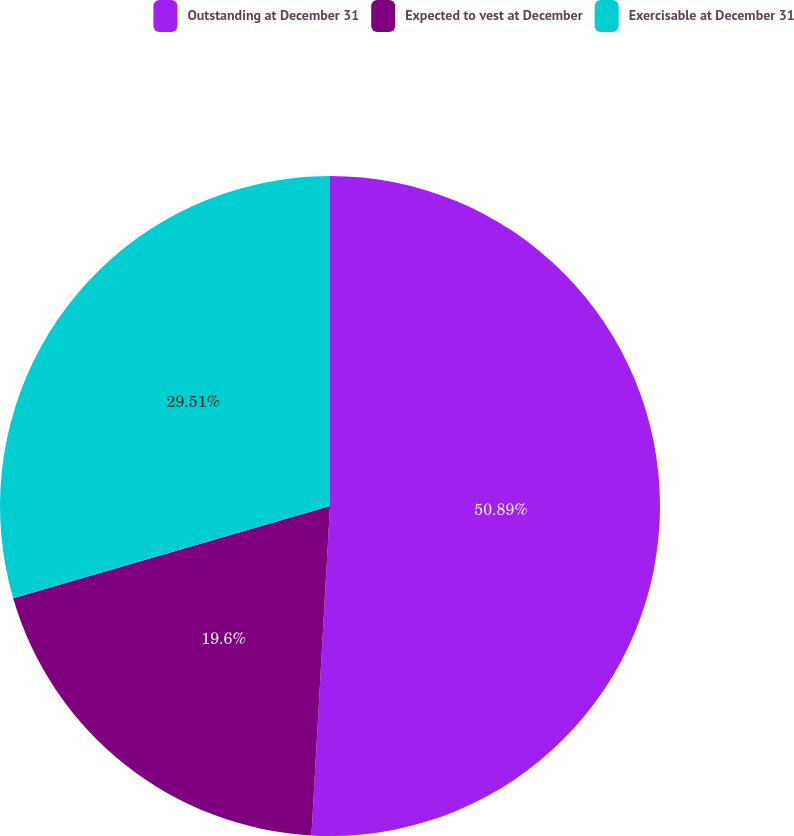Convert chart. <chart><loc_0><loc_0><loc_500><loc_500><pie_chart><fcel>Outstanding at December 31<fcel>Expected to vest at December<fcel>Exercisable at December 31<nl><fcel>50.9%<fcel>19.6%<fcel>29.51%<nl></chart> 